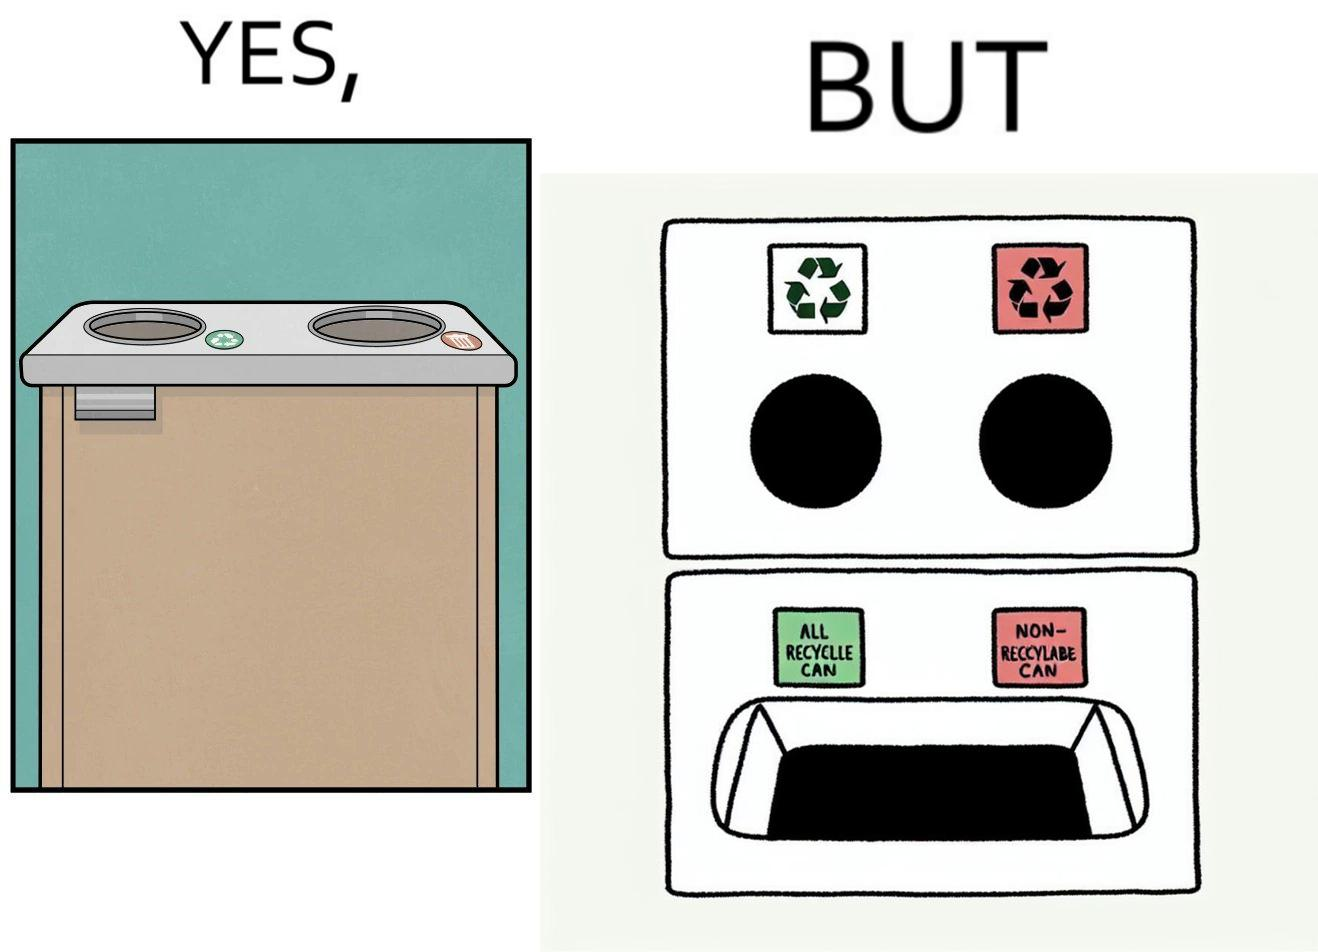Is there satirical content in this image? Yes, this image is satirical. 